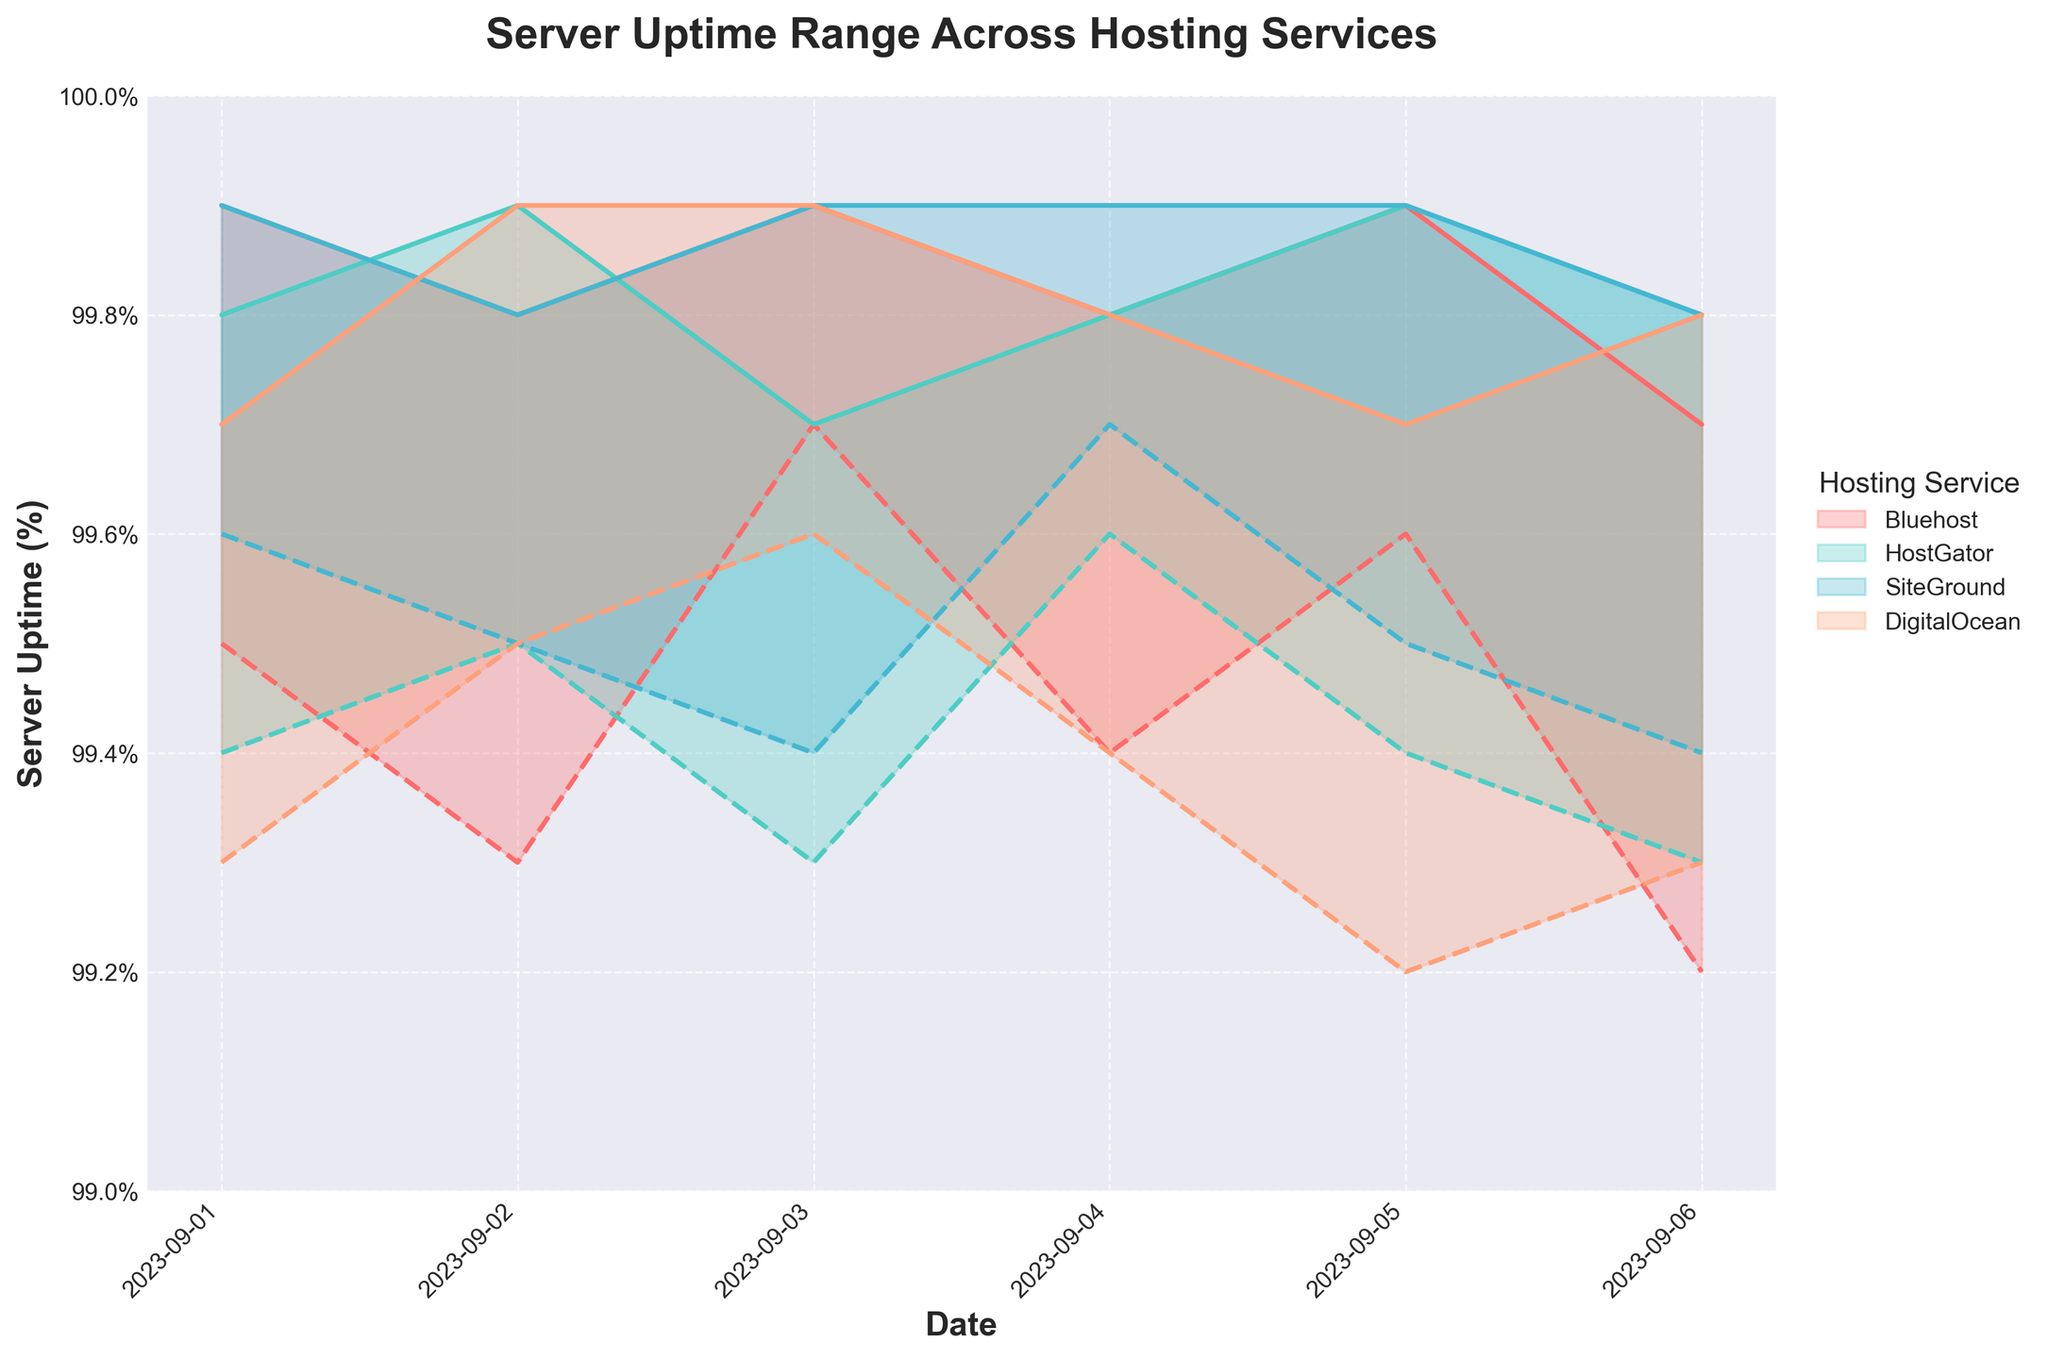What is the title of the chart? The title of the chart is located at the top and reads "Server Uptime Range Across Hosting Services".
Answer: Server Uptime Range Across Hosting Services How many hosting services are compared in the chart? By observing the different color-coded areas and the legend, we can count four unique hosting services being compared.
Answer: Four On which date did Bluehost have the lowest minimum uptime? By looking at the area for Bluehost and identifying the lowest point of the lower boundary line, we can see it was on September 6th.
Answer: September 6th What is the maximum uptime range observed for SiteGround on any given date? We identify the range between the maximum and minimum uptime lines for SiteGround and find that the widest gap (upper minus lower bound) is 0.5%, observed on September 4th.
Answer: 0.5% Which hosting service shows the most stable uptime range (smallest variation between Min and Max uptime) over the measured days? By visually comparing the areas of each service, SiteGround generally shows the smallest gap between Min and Max uptimes across the period.
Answer: SiteGround On what date did DigitalOcean have their highest maximum uptime? By checking the highest point on the upper boundary line for DigitalOcean, we find it was on September 3rd and September 2nd, both of which reached 99.9%.
Answer: September 2nd and September 3rd How does the minimum uptime of HostGator on September 4th compare to the maximum uptime of Bluehost on the same day? By examining the specific uptimes for both services on September 4th, HostGator's minimum uptime on that day (99.6%) is equal to the maximum uptime observed for Bluehost (99.8%).
Answer: HostGator's minimum is 0.2% less than Bluehost's maximum Which hosting service had the most frequent day-to-day fluctuations between their minimum and maximum uptime? By observing the variability and spread of the range areas over time, Bluehost shows more frequent and fluctuating day-to-day differences in their uptime measures.
Answer: Bluehost 